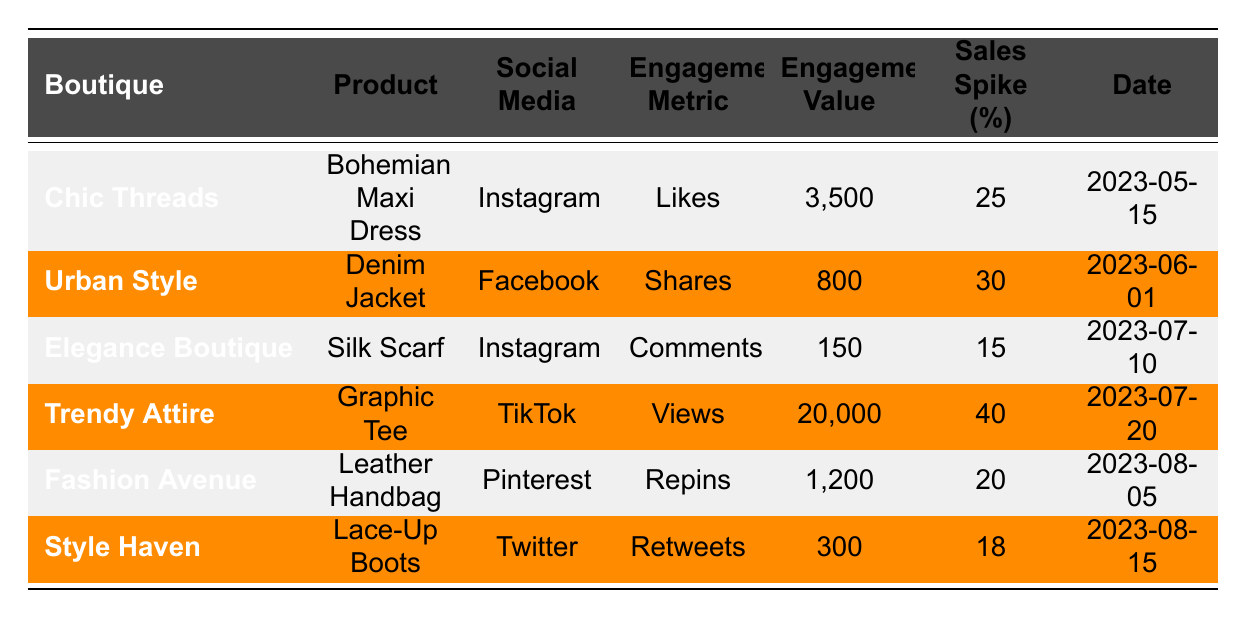What is the sales spike percentage for the Denim Jacket? The table shows that the Denim Jacket, sold by Urban Style, has a sales spike percentage of 30%. This information is directly listed in the corresponding row for this product.
Answer: 30 Which product had the highest engagement value? The highest engagement value in the table is for the Graphic Tee from Trendy Attire, with a value of 20,000 views on TikTok. This can be identified by comparing the Engagement Value across all products.
Answer: Graphic Tee What is the average sales spike percentage for products listed on Instagram? There are two products listed on Instagram: the Bohemian Maxi Dress with a sales spike of 25% and the Silk Scarf with a sales spike of 15%. To find the average, we sum these percentages (25 + 15 = 40) and divide by the number of products (2): 40/2 = 20%.
Answer: 20 Which social media channel had the lowest engagement value and what was it? The lowest engagement value is 150 from the Comments on Instagram for the Silk Scarf. This can be confirmed by scanning the Engagement Value column for the smallest number.
Answer: Instagram, 150 Did any product achieve a sales spike percentage greater than 25%? Yes, the products that achieved a sales spike percentage greater than 25% are the Denim Jacket (30%) and the Graphic Tee (40%). This is evident as both percentages exceed 25% as listed in the table.
Answer: Yes What is the total engagement value for all products listed in the table? To calculate the total engagement value, we add all individual engagement values: 3500 + 800 + 150 + 20000 + 1200 + 300 = 29750. This calculation can be performed by summing each Engagement Value across all rows.
Answer: 29750 How many products resulted in a sales spike percentage of less than 20%? From the table, there are two products with a sales spike percentage of less than 20%: the Silk Scarf (15%) and the Lace-Up Boots (18%). By analyzing each row, these two rows are identified.
Answer: 2 Which boutique has a product that ranks highest in sales spike percentage? The boutique with the highest sales spike percentage is Trendy Attire with the Graphic Tee at 40%. This can be determined by comparing all listed sales spike percentages.
Answer: Trendy Attire, Graphic Tee, 40 